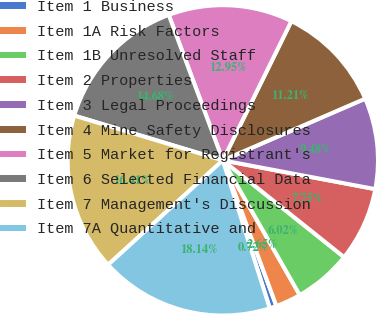Convert chart. <chart><loc_0><loc_0><loc_500><loc_500><pie_chart><fcel>Item 1 Business<fcel>Item 1A Risk Factors<fcel>Item 1B Unresolved Staff<fcel>Item 2 Properties<fcel>Item 3 Legal Proceedings<fcel>Item 4 Mine Safety Disclosures<fcel>Item 5 Market for Registrant's<fcel>Item 6 Selected Financial Data<fcel>Item 7 Management's Discussion<fcel>Item 7A Quantitative and<nl><fcel>0.72%<fcel>2.65%<fcel>6.02%<fcel>7.75%<fcel>9.48%<fcel>11.21%<fcel>12.95%<fcel>14.68%<fcel>16.41%<fcel>18.14%<nl></chart> 